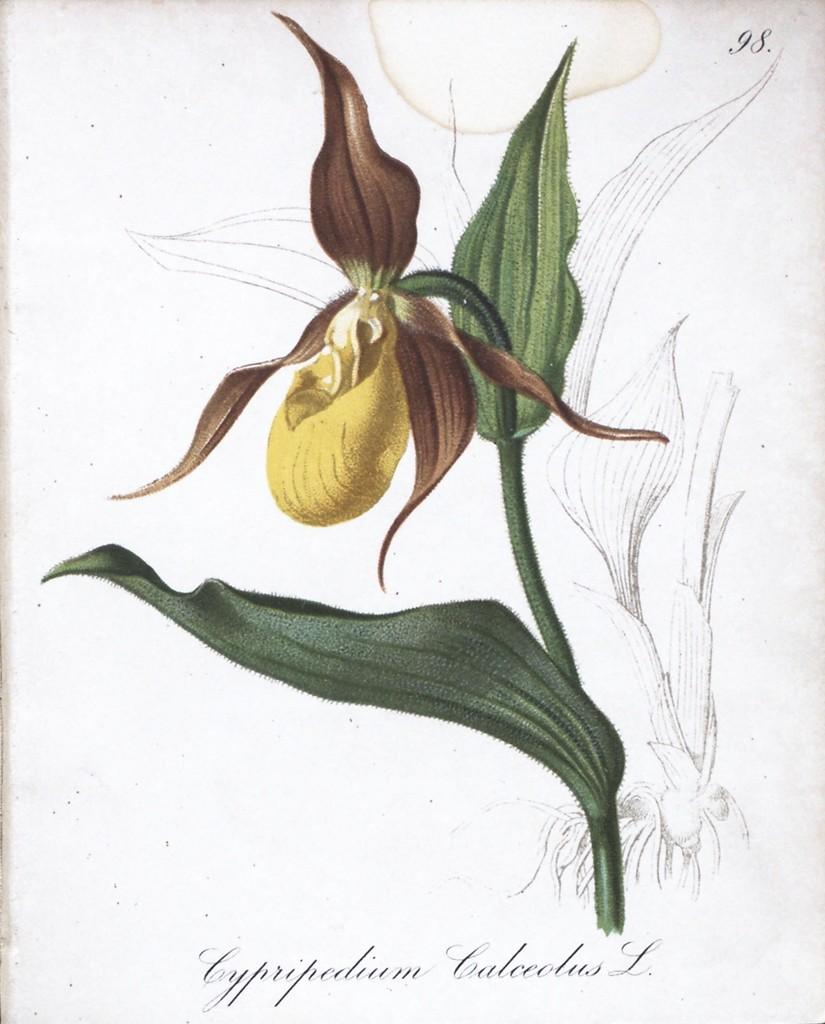What type of artwork is depicted in the image? The image is a painting. What is the main subject of the painting? There is a flower in the painting. What sign is the manager holding in the painting? There is no sign or manager present in the painting; it only features a flower. 